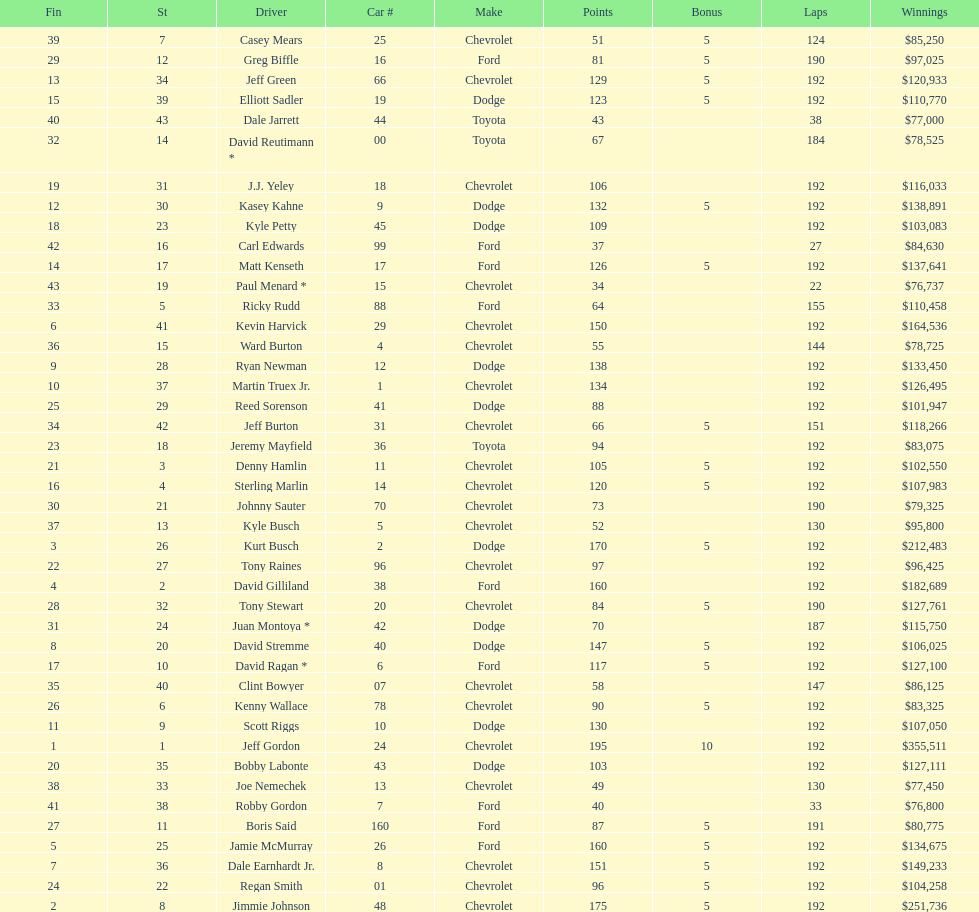How many race car drivers out of the 43 listed drove toyotas? 3. 